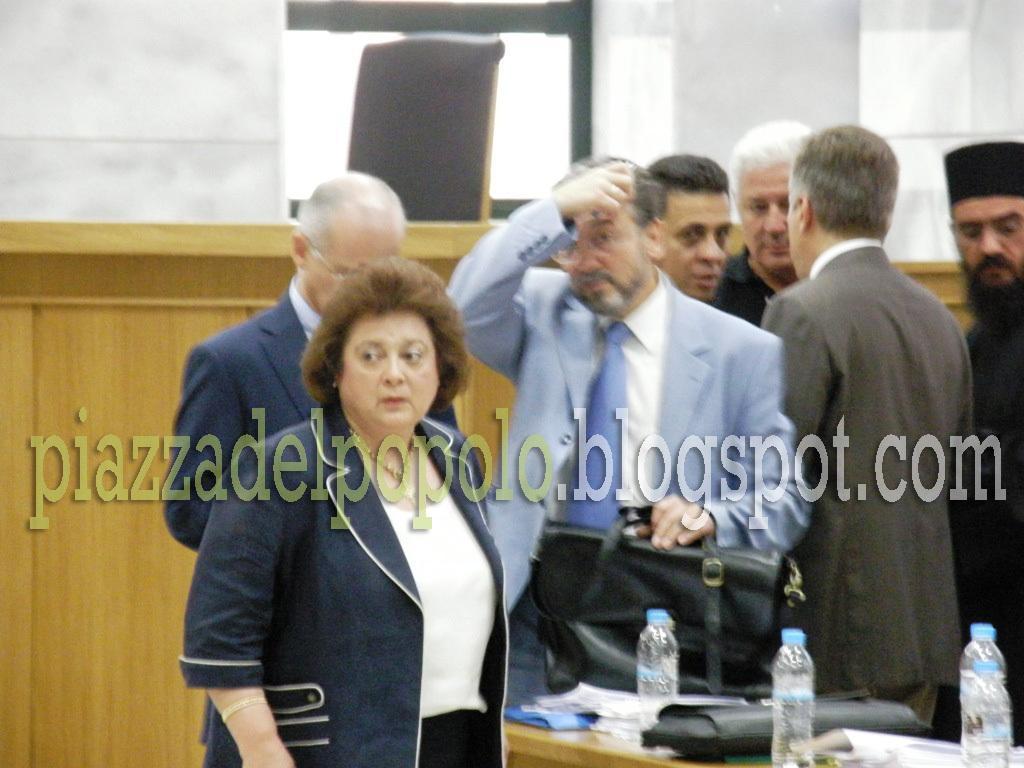How would you summarize this image in a sentence or two? In this image we can see a group of people standing and one among them is holding a bag, in front of them there is a table which consists of water bottles and a few other objects, behind them there is a wall and a window. 